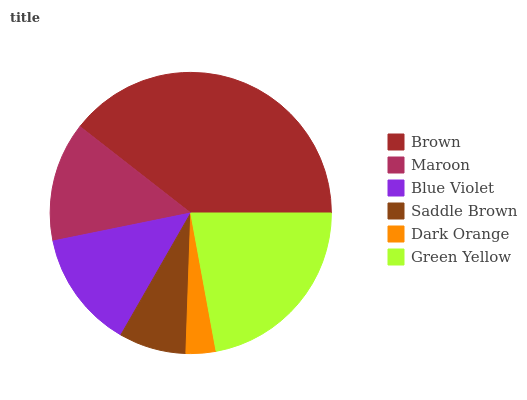Is Dark Orange the minimum?
Answer yes or no. Yes. Is Brown the maximum?
Answer yes or no. Yes. Is Maroon the minimum?
Answer yes or no. No. Is Maroon the maximum?
Answer yes or no. No. Is Brown greater than Maroon?
Answer yes or no. Yes. Is Maroon less than Brown?
Answer yes or no. Yes. Is Maroon greater than Brown?
Answer yes or no. No. Is Brown less than Maroon?
Answer yes or no. No. Is Maroon the high median?
Answer yes or no. Yes. Is Blue Violet the low median?
Answer yes or no. Yes. Is Saddle Brown the high median?
Answer yes or no. No. Is Brown the low median?
Answer yes or no. No. 